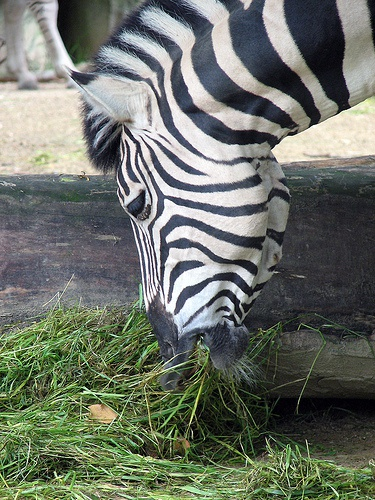Describe the objects in this image and their specific colors. I can see a zebra in black, lightgray, gray, and darkgray tones in this image. 